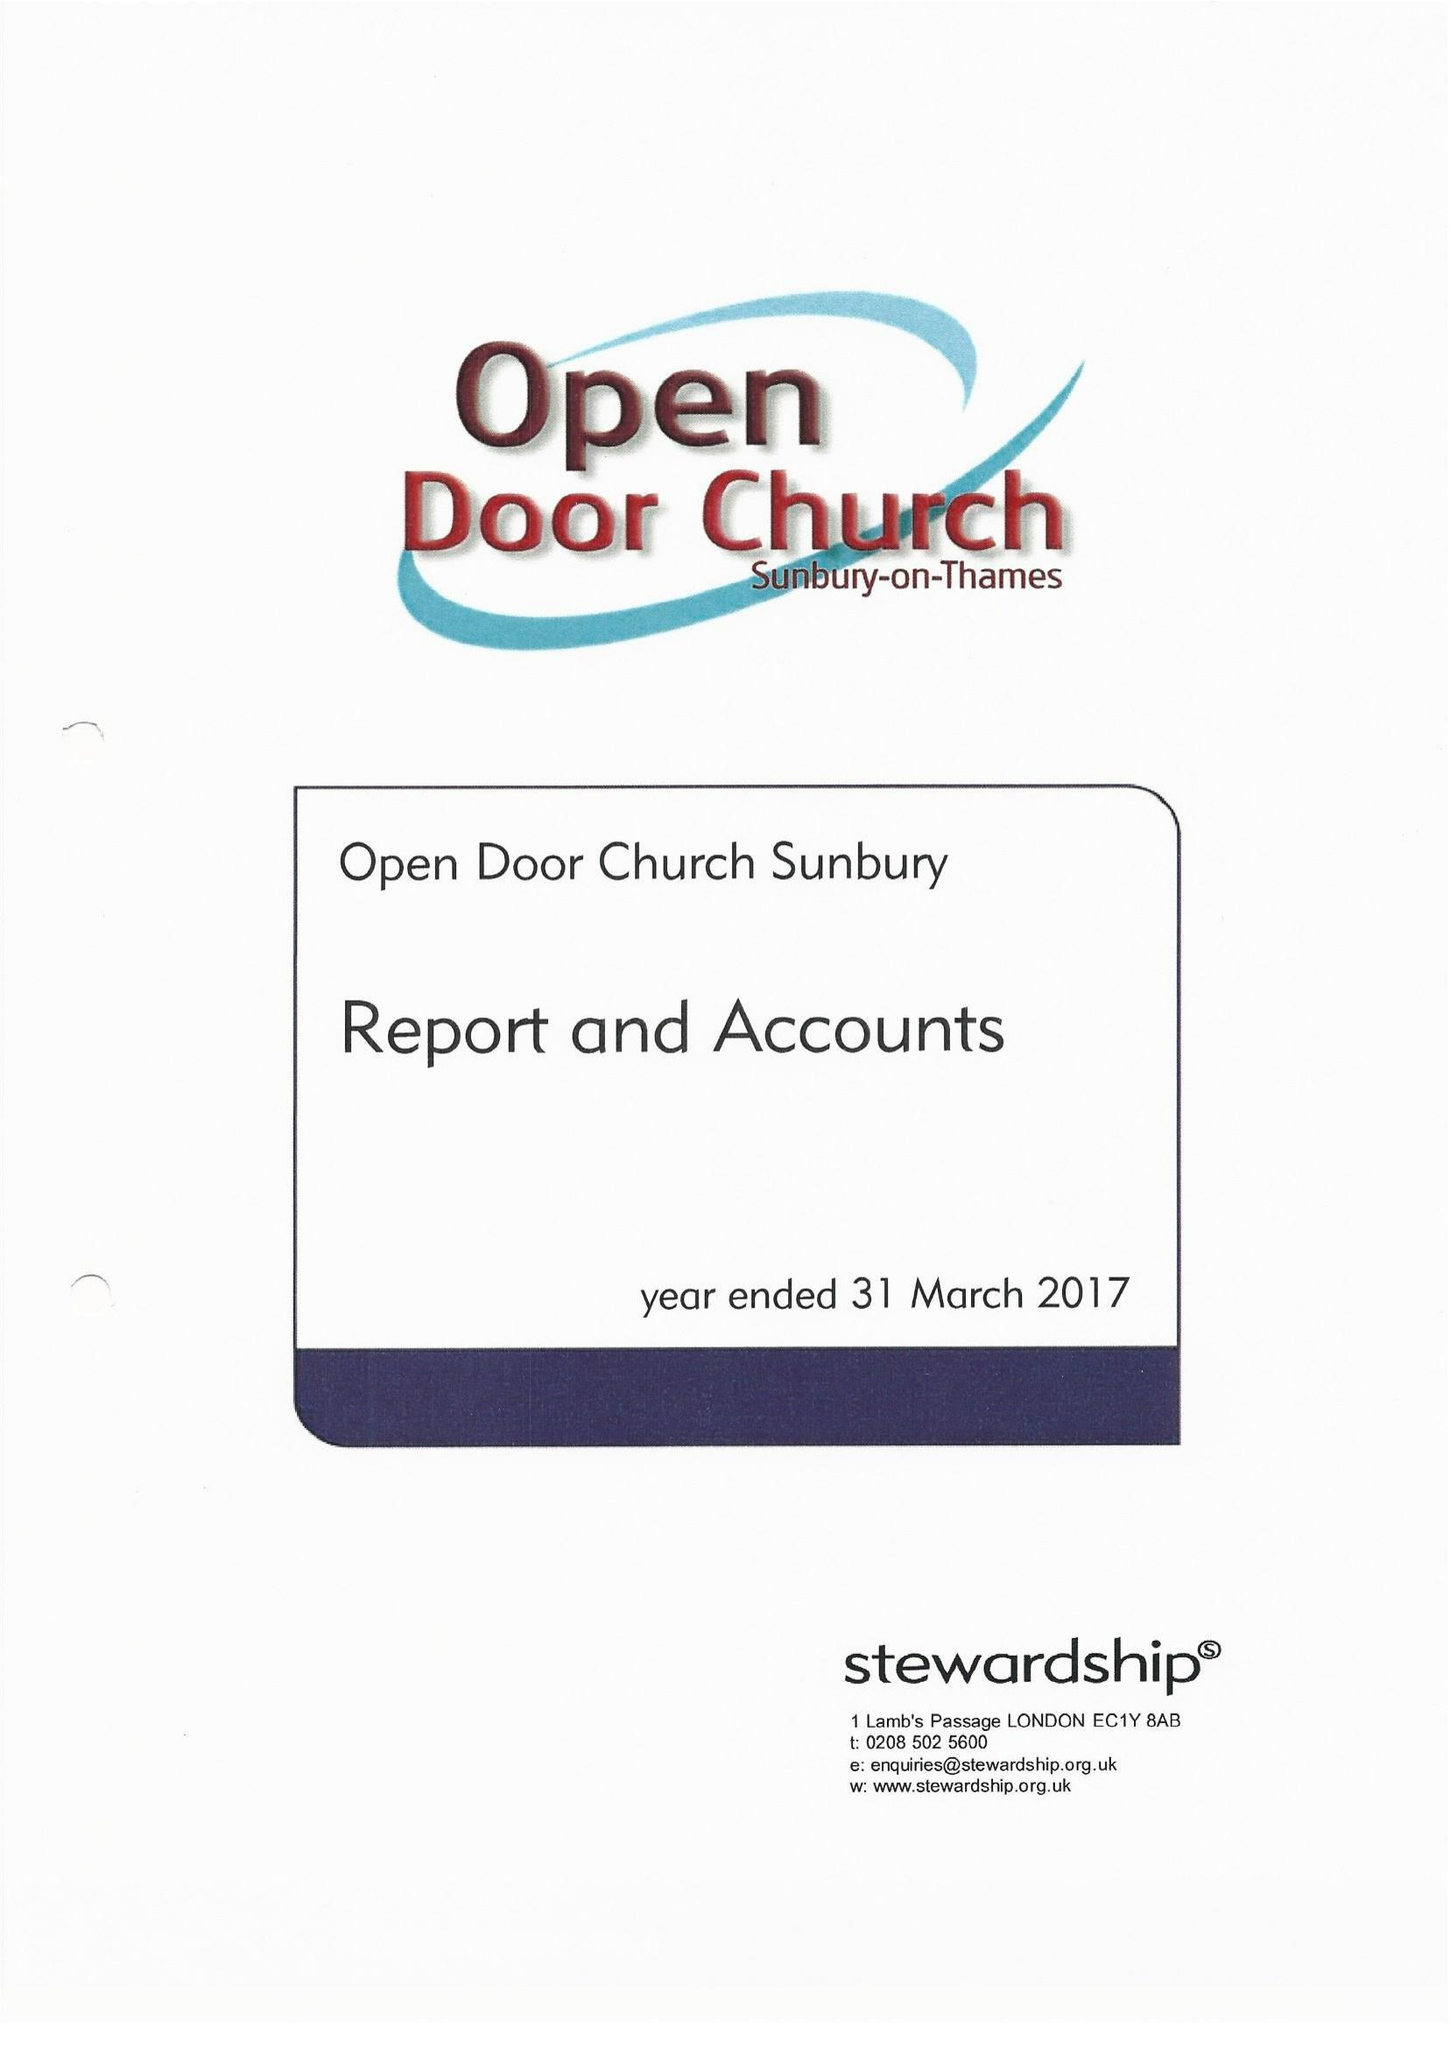What is the value for the income_annually_in_british_pounds?
Answer the question using a single word or phrase. 156758.00 